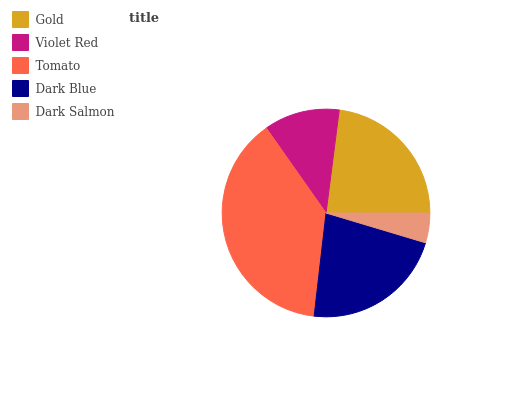Is Dark Salmon the minimum?
Answer yes or no. Yes. Is Tomato the maximum?
Answer yes or no. Yes. Is Violet Red the minimum?
Answer yes or no. No. Is Violet Red the maximum?
Answer yes or no. No. Is Gold greater than Violet Red?
Answer yes or no. Yes. Is Violet Red less than Gold?
Answer yes or no. Yes. Is Violet Red greater than Gold?
Answer yes or no. No. Is Gold less than Violet Red?
Answer yes or no. No. Is Dark Blue the high median?
Answer yes or no. Yes. Is Dark Blue the low median?
Answer yes or no. Yes. Is Violet Red the high median?
Answer yes or no. No. Is Tomato the low median?
Answer yes or no. No. 